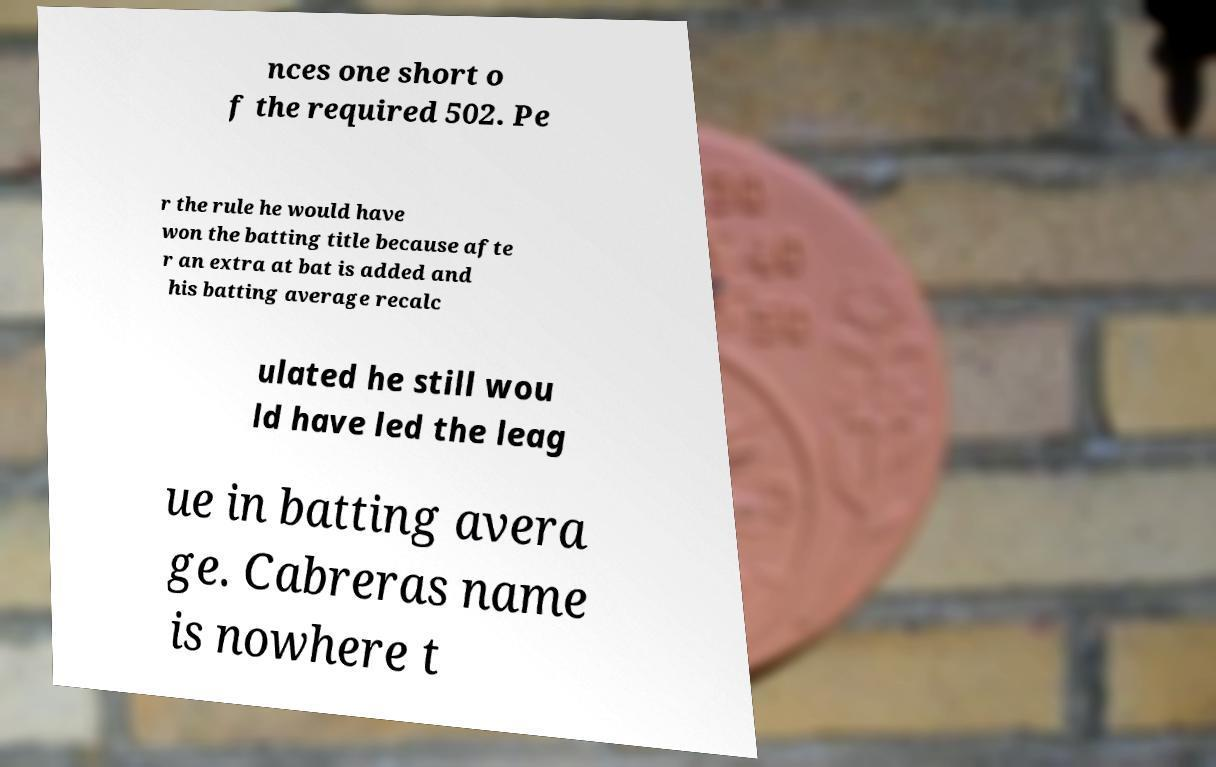Can you accurately transcribe the text from the provided image for me? nces one short o f the required 502. Pe r the rule he would have won the batting title because afte r an extra at bat is added and his batting average recalc ulated he still wou ld have led the leag ue in batting avera ge. Cabreras name is nowhere t 